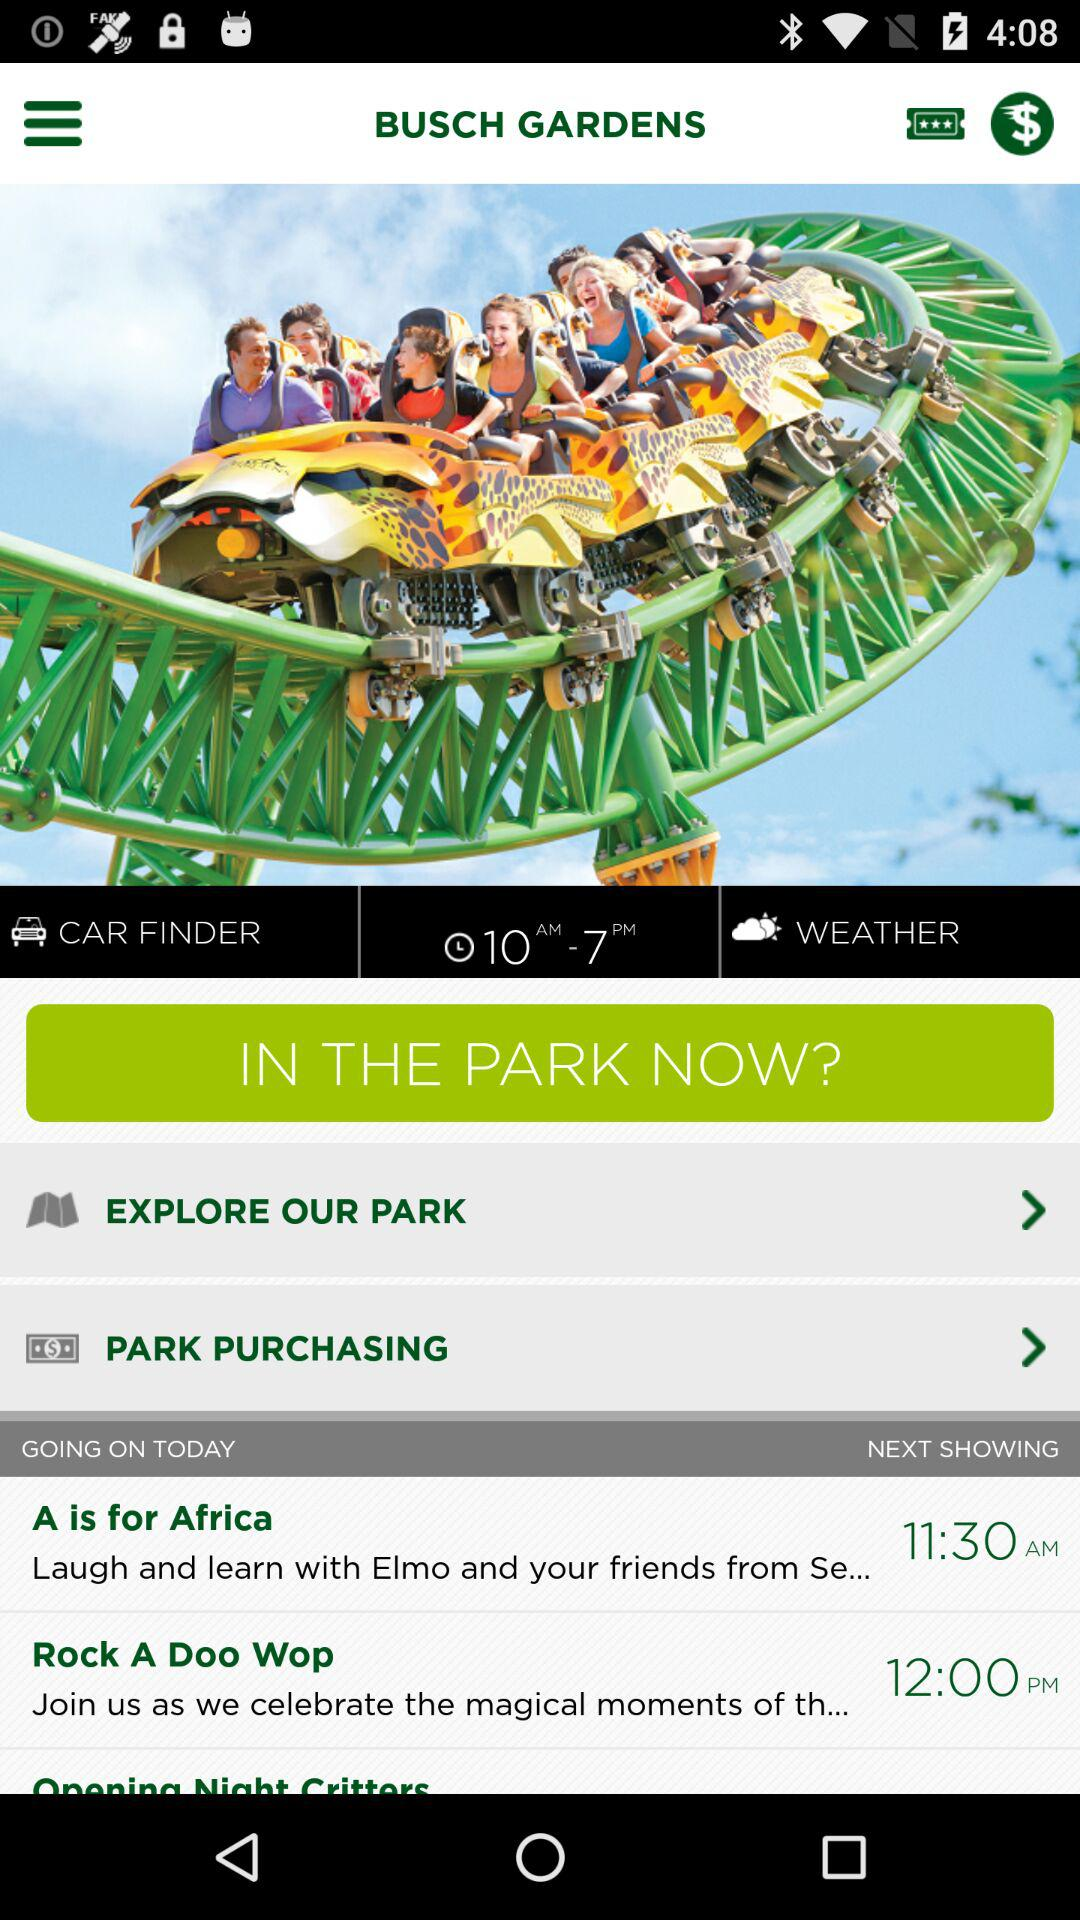What is the timing? The time is 10 AM–7 PM. 